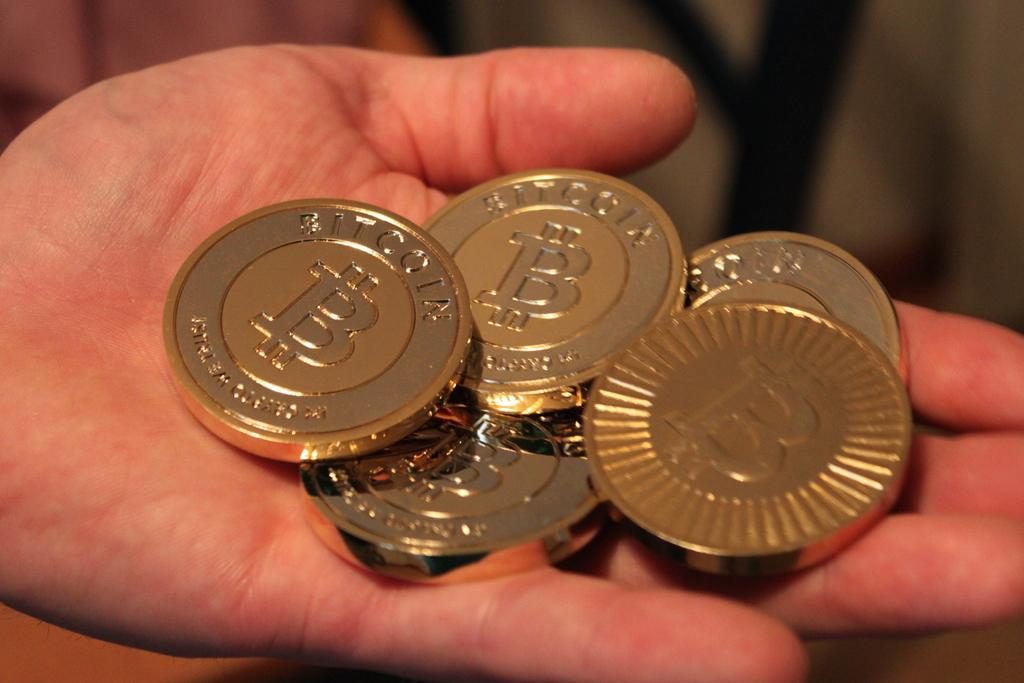Provide a one-sentence caption for the provided image. a set of gold Bitcoins in someone's palm. 